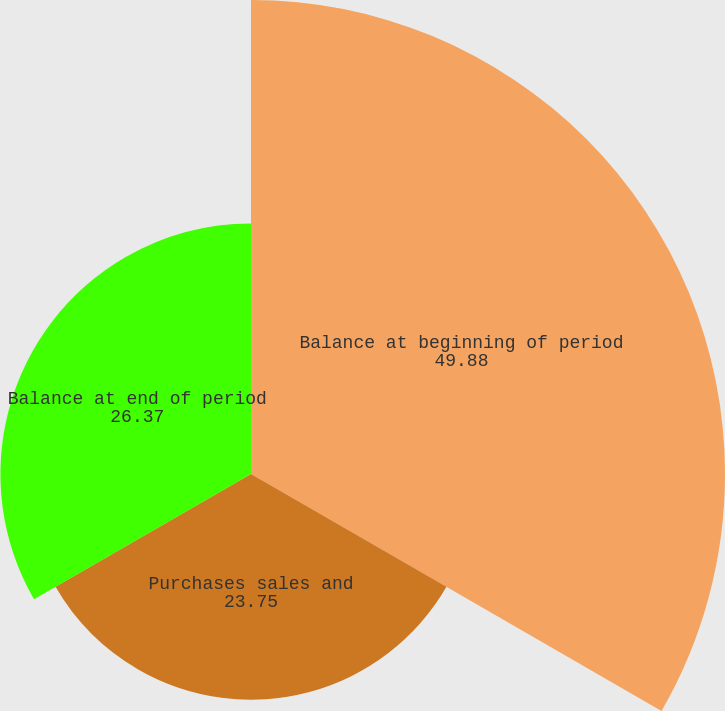Convert chart. <chart><loc_0><loc_0><loc_500><loc_500><pie_chart><fcel>Balance at beginning of period<fcel>Purchases sales and<fcel>Balance at end of period<nl><fcel>49.88%<fcel>23.75%<fcel>26.37%<nl></chart> 